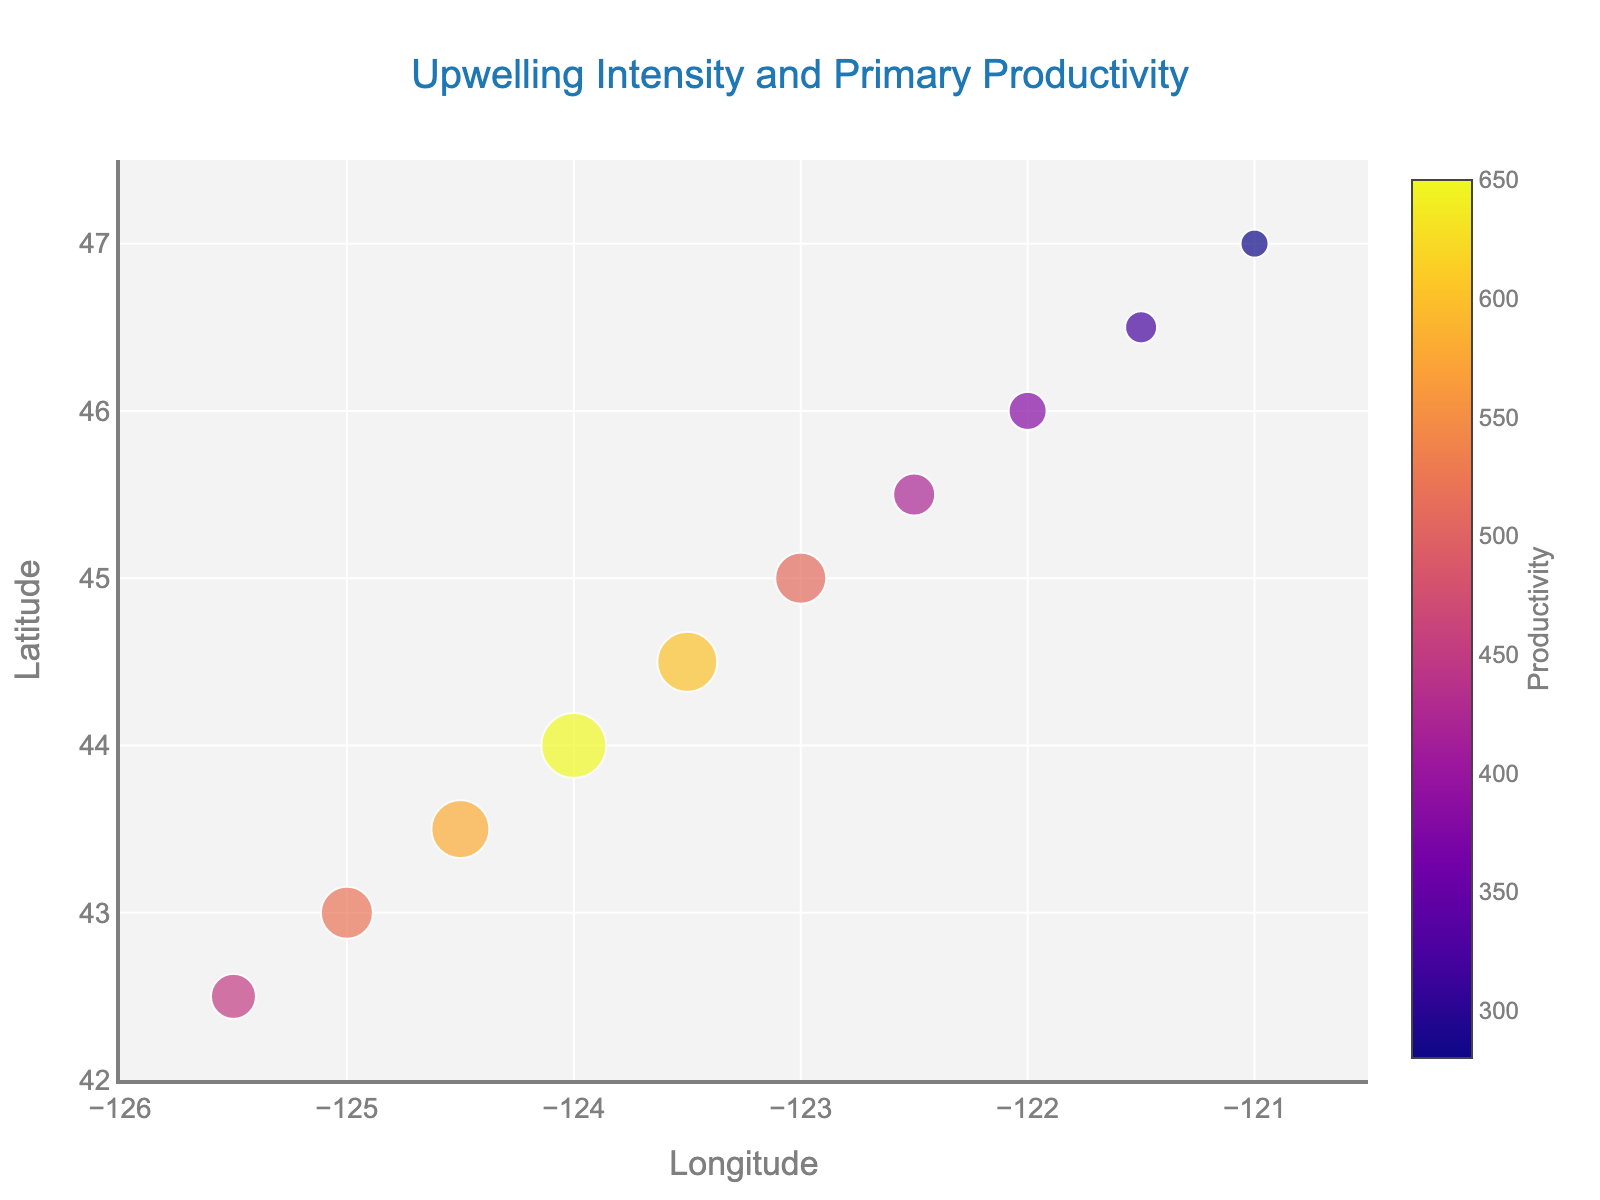How many data points are shown on the figure? The data shows the locations of upwelling with associated vectors, and the plot also visualizes primary productivity at each point. Counting the x or y coordinates can determine the number of data points.
Answer: 10 From which latitude to which latitude does the plot range? By observing the y-axis of the plot, we can see the range of latitudes where the data points are positioned from the smallest to the largest y value.
Answer: 42.5 to 47.0 Which location shows the highest primary productivity and what is its value? Examine the size and color of the markers representing productivity on the plot. The largest and darkest marker on the scatter plot indicates the highest primary productivity. The tooltip provides the exact value.
Answer: Latitude 44.0, 650 How does upwelling intensity change as you move north along the coast? By observing the vectors (quivers) represented on the plot, discern if the magnitude and direction of these vectors show a pattern in their intensity (length of vectors) as you move from south to north on the y-axis.
Answer: Decreases Compare primary productivity at the southernmost and northernmost points. Identify the markers at the southernmost (Latitude 42.5) and northernmost (Latitude 47.0) points. Compare their sizes and colors which indicate their productivity values.
Answer: Southernmost: 450, Northernmost: 280 Is there a pattern in the relationship between upwelling intensity and primary productivity? Look at how the size and direction of the vectors (indicating upwelling intensity) correspond to the size and color of the markers (indicating productivity). A clear pattern would mean more intense upwelling is associated with higher productivity.
Answer: Higher upwelling intensity typically corresponds to higher productivity What is the longitudinal range of the plot? The range can be found by examining the x-axis of the figure, which shows the extent from the smallest to the largest x values.
Answer: 121.0 to 125.5 Which location shows the weakest upwelling and what is its latitude? By identifying the smallest vector on the plot, we can determine where the weakest upwelling occurs. The latitude can be read from the y-coordinate of that vector.
Answer: Latitude 47.0 What is the overall trend in primary productivity from south to north? Examine the scatter plot markers representing primary productivity from the lowest to the highest latitude. Assess if there is a general increase, decrease, or other trend in productivity values.
Answer: Decrease At latitude 45.0, what is the direction and intensity of the upwelling vector? Locate the pointer for latitude 45.0 on the plot to find out the direction (angle) and intensity (length) of the vector at that point as represented by the quiver.
Answer: Direction: Northwest, Intensity: 0.16 